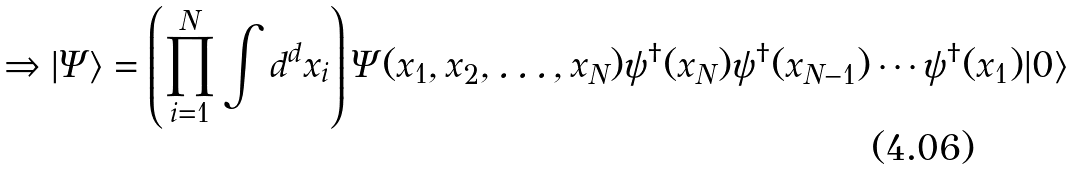<formula> <loc_0><loc_0><loc_500><loc_500>\Rightarrow | \Psi \rangle = \left ( \prod _ { i = 1 } ^ { N } \int d ^ { d } x _ { i } \right ) \Psi ( x _ { 1 } , x _ { 2 } , \dots , x _ { N } ) \psi ^ { \dagger } ( x _ { N } ) \psi ^ { \dagger } ( x _ { N - 1 } ) \cdots \psi ^ { \dagger } ( x _ { 1 } ) | 0 \rangle</formula> 